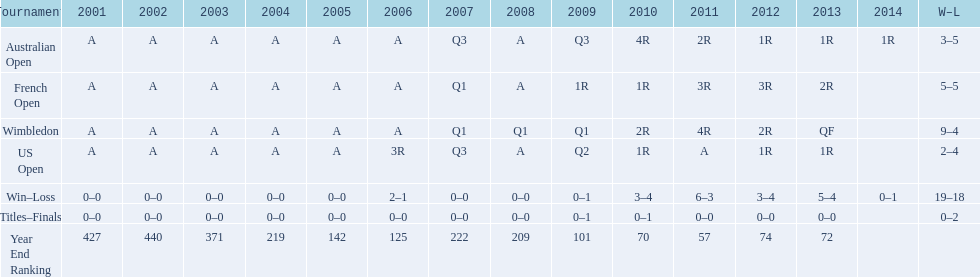In what years did only a single loss occur? 2006, 2009, 2014. 